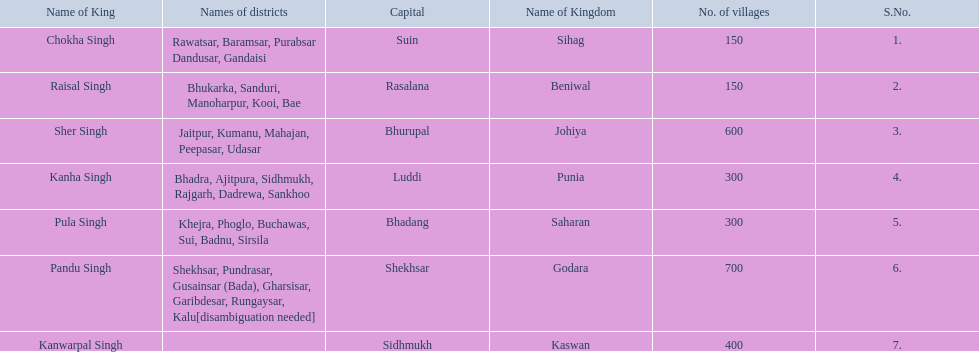Which kingdom contained the least amount of villages along with sihag? Beniwal. Which kingdom contained the most villages? Godara. Which village was tied at second most villages with godara? Johiya. 